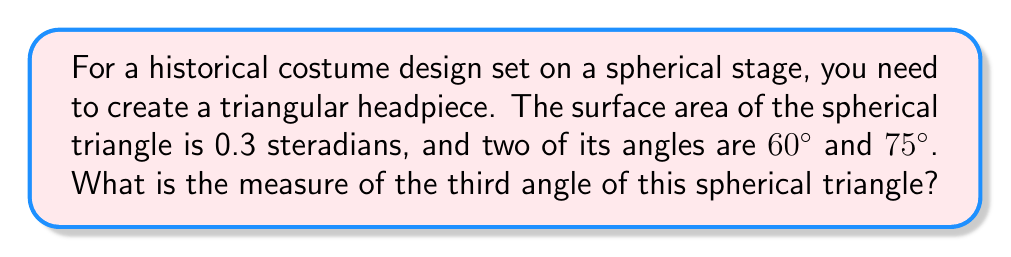Solve this math problem. Let's approach this step-by-step using the principles of spherical geometry:

1) In spherical geometry, we use the formula for the area of a spherical triangle:

   $$A = R^2(α + β + γ - π)$$

   where A is the area, R is the radius of the sphere, and α, β, and γ are the angles of the triangle in radians.

2) We're given the area in steradians, which means R = 1 (unit sphere). So our equation becomes:

   $$0.3 = α + β + γ - π$$

3) We know two of the angles: 60° and 75°. Let's convert these to radians:
   
   60° = $\frac{π}{3}$ radians
   75° = $\frac{5π}{12}$ radians

4) Let's call our unknown angle θ. We can now set up our equation:

   $$0.3 = \frac{π}{3} + \frac{5π}{12} + θ - π$$

5) Simplify the right side:

   $$0.3 = \frac{4π}{12} + \frac{5π}{12} + θ - π = \frac{9π}{12} - π + θ = -\frac{3π}{12} + θ$$

6) Solve for θ:

   $$θ = 0.3 + \frac{3π}{12} = 0.3 + 0.7853981... = 1.0853981...$$

7) Convert back to degrees:

   $$θ = 1.0853981... * \frac{180}{π} = 62.18°$$

Thus, the third angle of the spherical triangle is approximately 62.18°.
Answer: 62.18° 